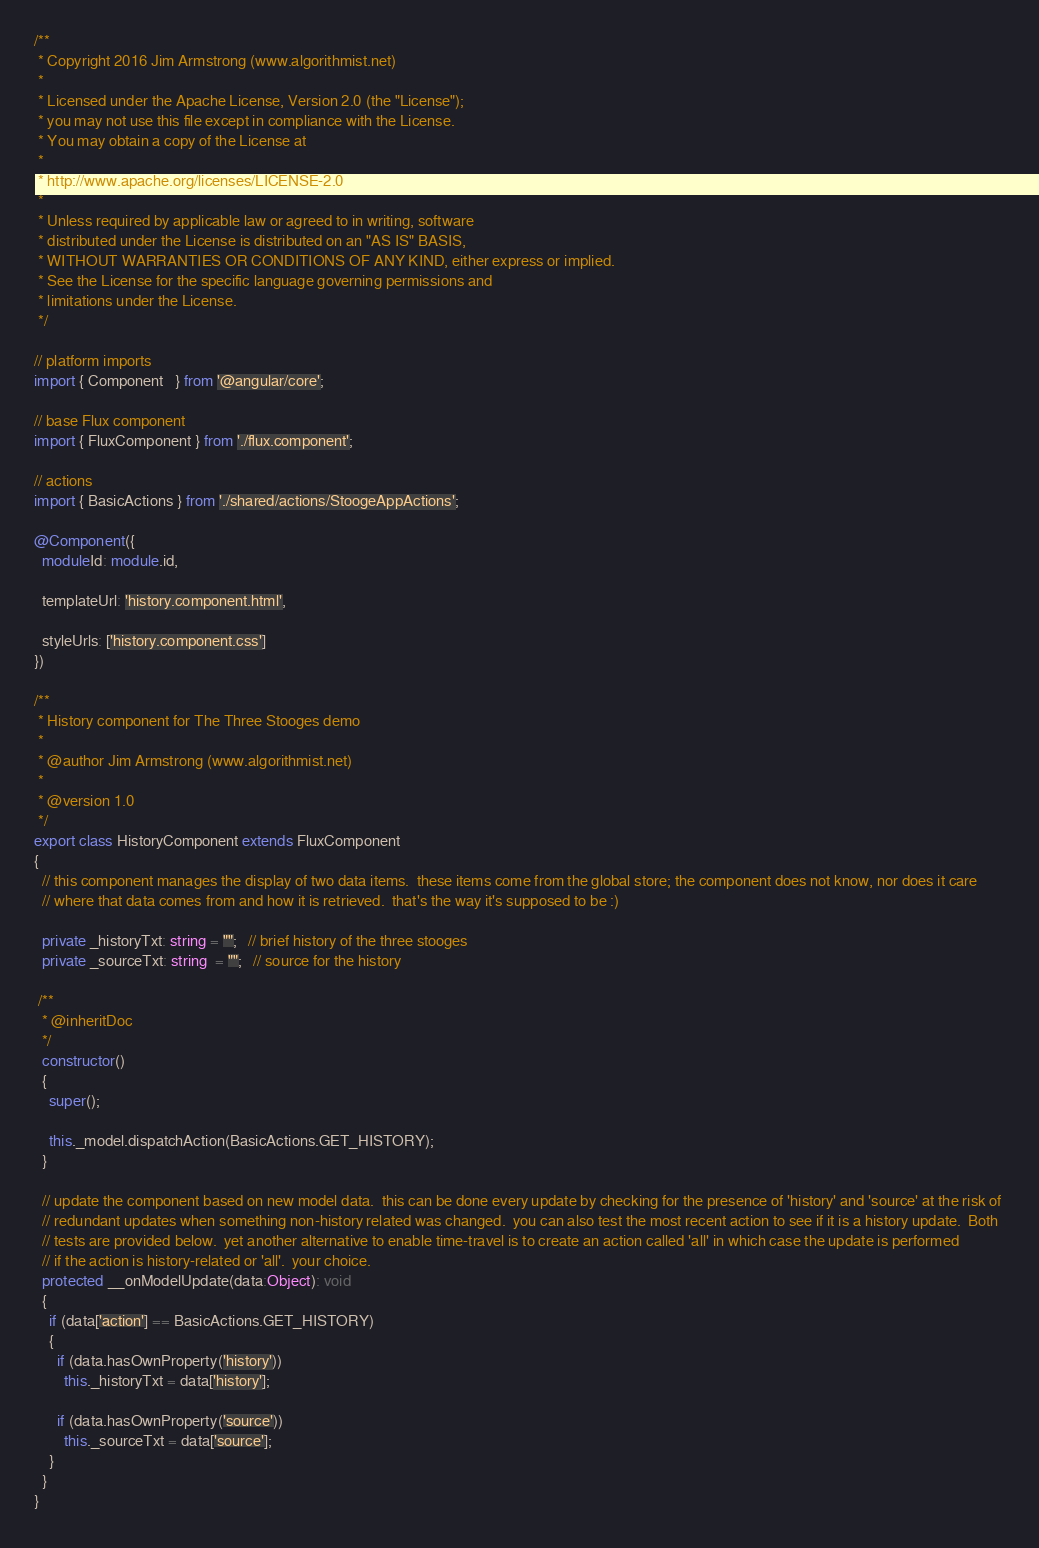<code> <loc_0><loc_0><loc_500><loc_500><_TypeScript_>/** 
 * Copyright 2016 Jim Armstrong (www.algorithmist.net)
 *
 * Licensed under the Apache License, Version 2.0 (the "License");
 * you may not use this file except in compliance with the License.
 * You may obtain a copy of the License at
 *
 * http://www.apache.org/licenses/LICENSE-2.0
 *
 * Unless required by applicable law or agreed to in writing, software
 * distributed under the License is distributed on an "AS IS" BASIS,
 * WITHOUT WARRANTIES OR CONDITIONS OF ANY KIND, either express or implied.
 * See the License for the specific language governing permissions and
 * limitations under the License.
 */

// platform imports
import { Component   } from '@angular/core';

// base Flux component
import { FluxComponent } from './flux.component';

// actions
import { BasicActions } from './shared/actions/StoogeAppActions';

@Component({
  moduleId: module.id,

  templateUrl: 'history.component.html',

  styleUrls: ['history.component.css']
})

/**
 * History component for The Three Stooges demo 
 *
 * @author Jim Armstrong (www.algorithmist.net)
 *
 * @version 1.0
 */
export class HistoryComponent extends FluxComponent
{
  // this component manages the display of two data items.  these items come from the global store; the component does not know, nor does it care
  // where that data comes from and how it is retrieved.  that's the way it's supposed to be :)

  private _historyTxt: string = "";   // brief history of the three stooges
  private _sourceTxt: string  = "";   // source for the history

 /**
  * @inheritDoc
  */
  constructor()
  {
    super();

    this._model.dispatchAction(BasicActions.GET_HISTORY);
  }

  // update the component based on new model data.  this can be done every update by checking for the presence of 'history' and 'source' at the risk of 
  // redundant updates when something non-history related was changed.  you can also test the most recent action to see if it is a history update.  Both
  // tests are provided below.  yet another alternative to enable time-travel is to create an action called 'all' in which case the update is performed
  // if the action is history-related or 'all'.  your choice.
  protected __onModelUpdate(data:Object): void
  {
    if (data['action'] == BasicActions.GET_HISTORY)
    {
      if (data.hasOwnProperty('history'))
        this._historyTxt = data['history'];

      if (data.hasOwnProperty('source'))
        this._sourceTxt = data['source'];
    }
  }
}
</code> 